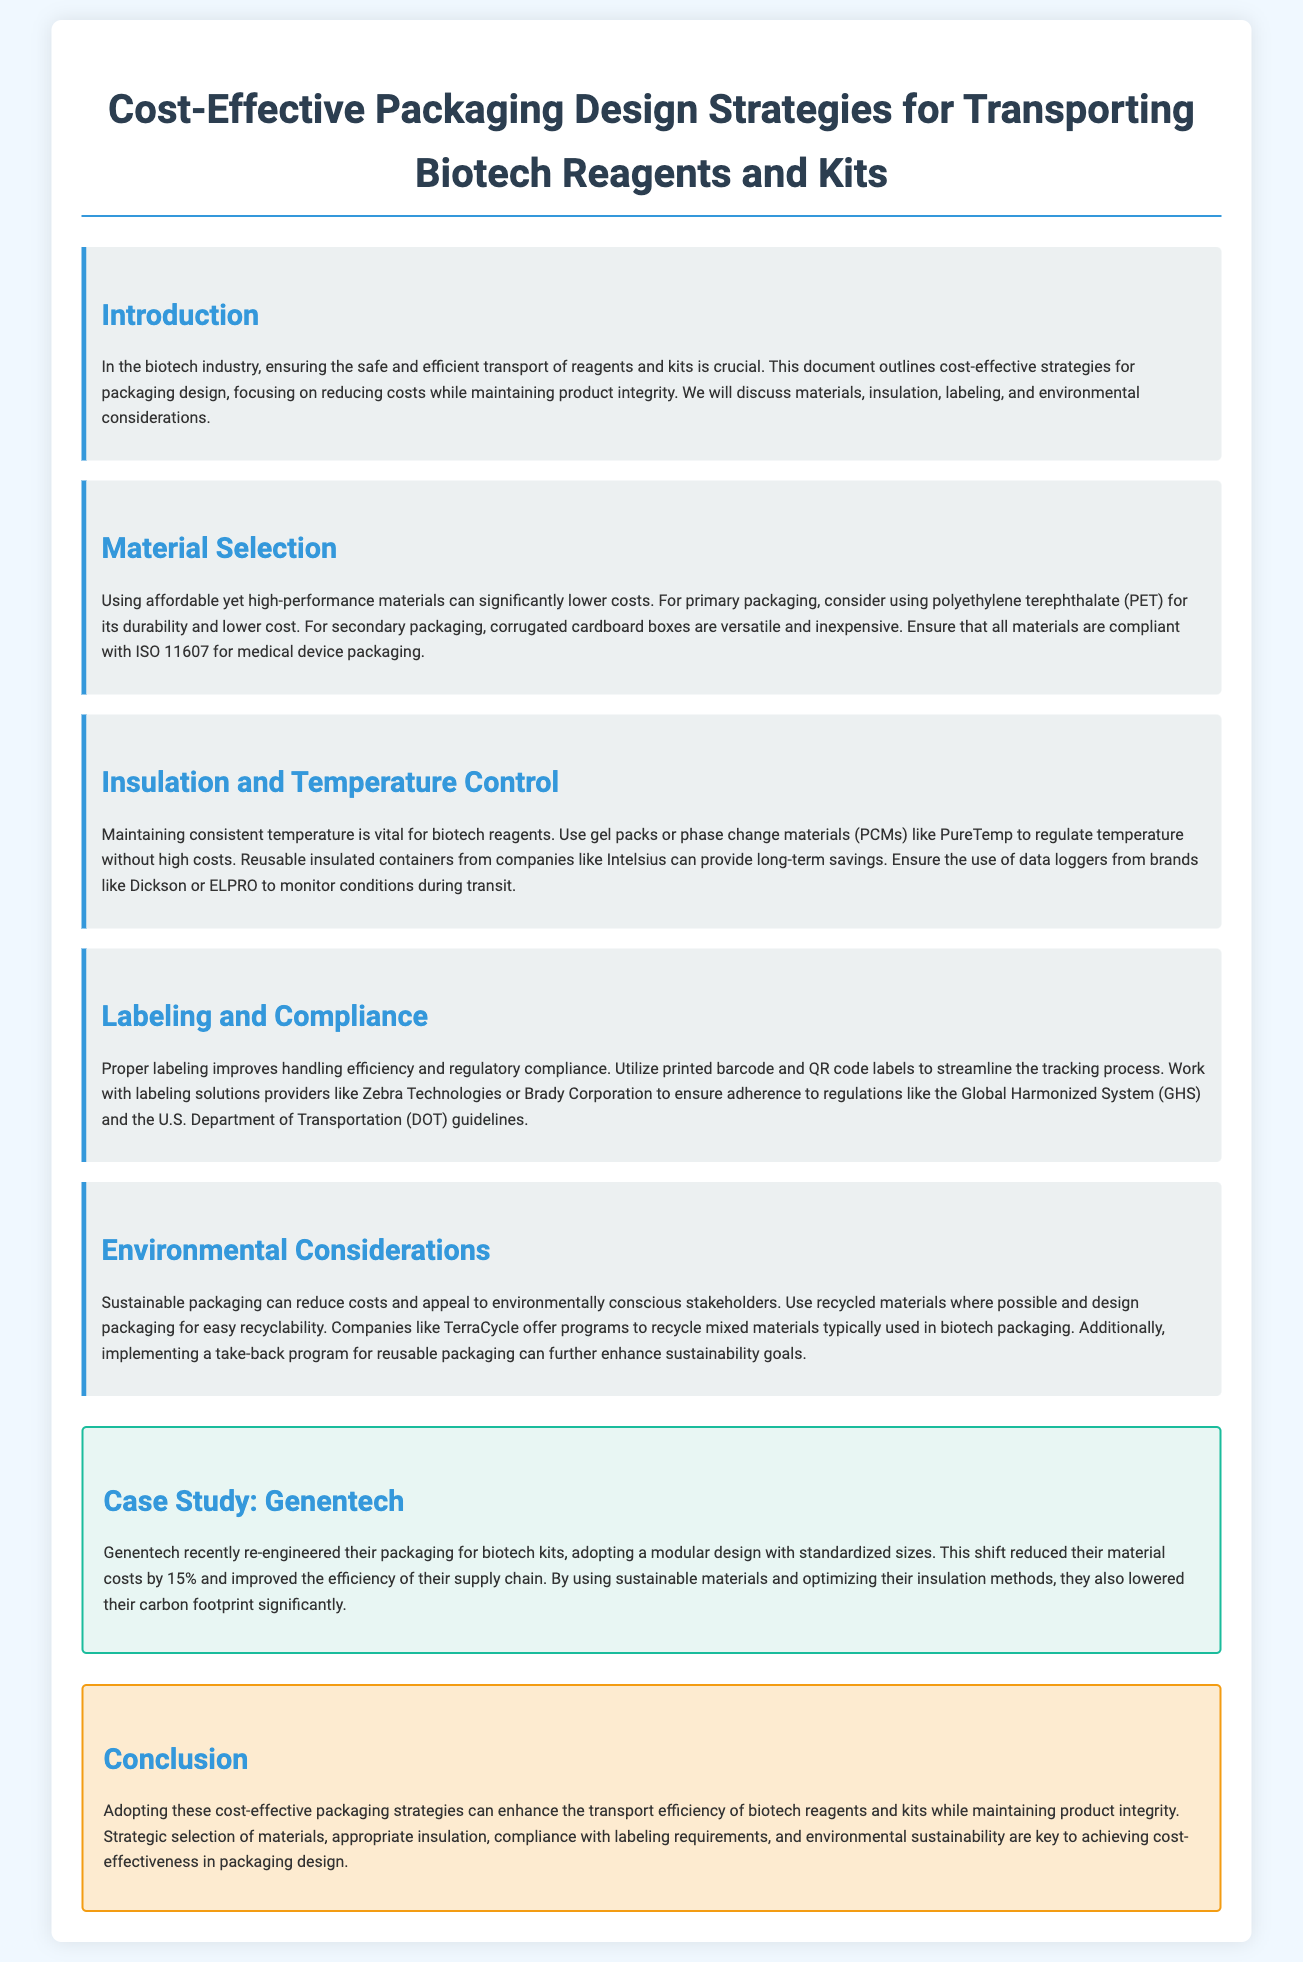what is the main focus of the document? The document outlines strategies for packaging design in the biotech industry, emphasizing cost-effectiveness while maintaining product integrity.
Answer: cost-effective packaging design strategies which material is suggested for primary packaging? The document recommends using polyethylene terephthalate (PET) for its durability and lower cost.
Answer: polyethylene terephthalate (PET) what type of containers can provide long-term savings? The document mentions reusable insulated containers as a solution for cost-effective temperature control.
Answer: reusable insulated containers by what percentage did Genentech reduce their material costs? Genentech's re-engineering of packaging resulted in a material cost reduction of 15%.
Answer: 15% what is one environmental consideration mentioned in the document? The document suggests using recycled materials where possible to enhance sustainability.
Answer: recycled materials what type of technologies does the document recommend for labeling? The document recommends using printed barcode and QR code labels to improve tracking and compliance.
Answer: barcode and QR code labels which company is mentioned as a provider of labeling solutions? Zebra Technologies is mentioned as a provider for labeling compliance solutions.
Answer: Zebra Technologies what is a significant benefit of sustainable packaging mentioned? The document states that sustainable packaging can reduce costs and appeal to environmentally conscious stakeholders.
Answer: reduce costs what is the purpose of data loggers in packaging? Data loggers are used to monitor conditions during transit to ensure product integrity.
Answer: monitor conditions during transit 